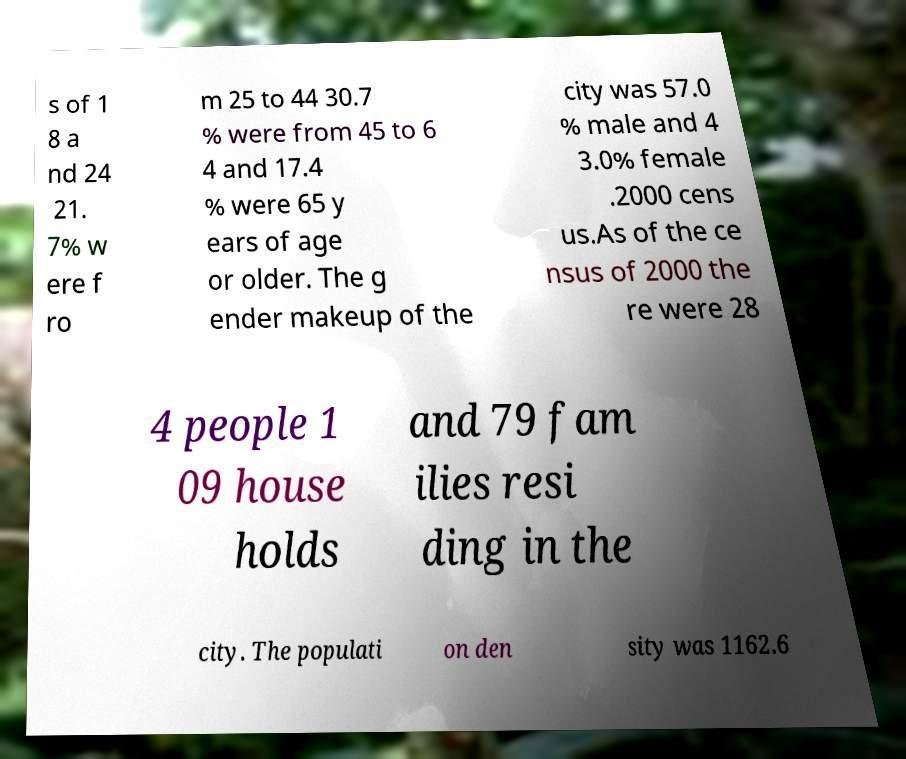Please read and relay the text visible in this image. What does it say? s of 1 8 a nd 24 21. 7% w ere f ro m 25 to 44 30.7 % were from 45 to 6 4 and 17.4 % were 65 y ears of age or older. The g ender makeup of the city was 57.0 % male and 4 3.0% female .2000 cens us.As of the ce nsus of 2000 the re were 28 4 people 1 09 house holds and 79 fam ilies resi ding in the city. The populati on den sity was 1162.6 